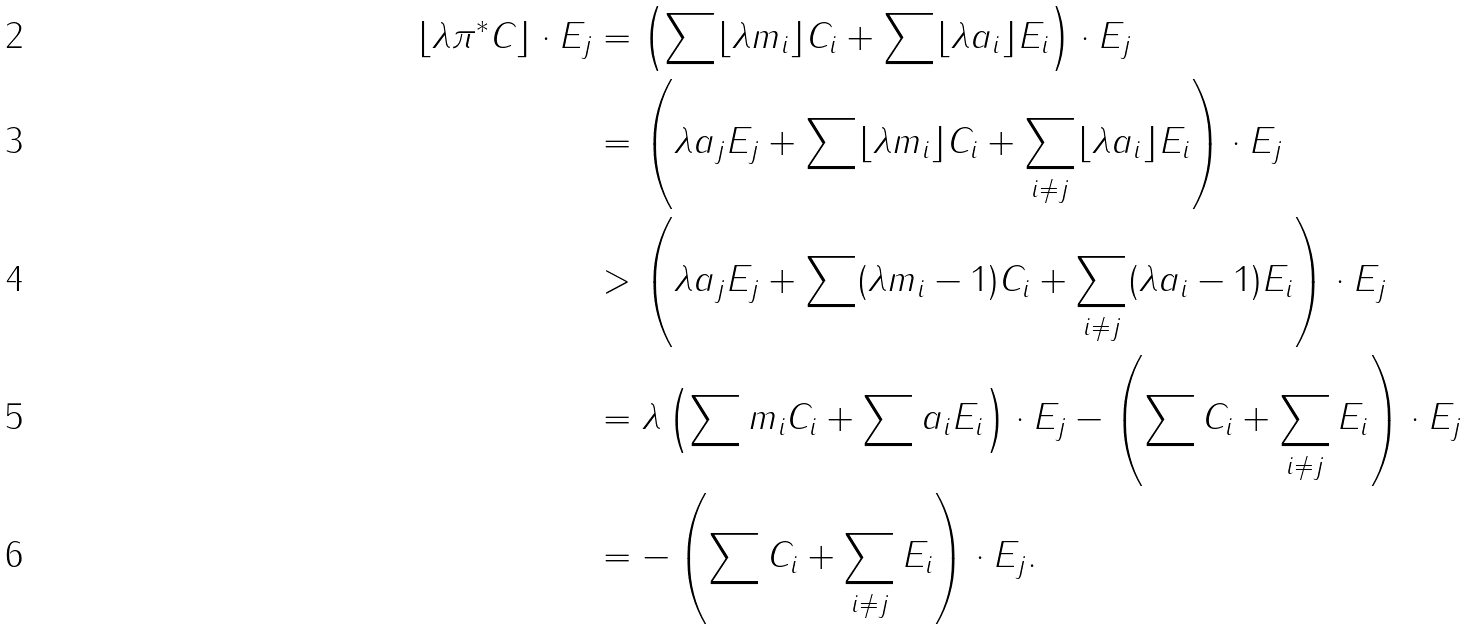Convert formula to latex. <formula><loc_0><loc_0><loc_500><loc_500>\lfloor \lambda \pi ^ { * } C \rfloor \cdot E _ { j } & = \left ( \sum \lfloor \lambda m _ { i } \rfloor C _ { i } + \sum \lfloor \lambda a _ { i } \rfloor E _ { i } \right ) \cdot E _ { j } \\ & = \left ( \lambda a _ { j } E _ { j } + \sum \lfloor \lambda m _ { i } \rfloor C _ { i } + \sum _ { i \neq j } \lfloor \lambda a _ { i } \rfloor E _ { i } \right ) \cdot E _ { j } \\ & > \left ( \lambda a _ { j } E _ { j } + \sum ( \lambda m _ { i } - 1 ) C _ { i } + \sum _ { i \neq j } ( \lambda a _ { i } - 1 ) E _ { i } \right ) \cdot E _ { j } \\ & = \lambda \left ( \sum m _ { i } C _ { i } + \sum a _ { i } E _ { i } \right ) \cdot E _ { j } - \left ( \sum C _ { i } + \sum _ { i \neq j } E _ { i } \right ) \cdot E _ { j } \\ & = - \left ( \sum C _ { i } + \sum _ { i \neq j } E _ { i } \right ) \cdot E _ { j } .</formula> 